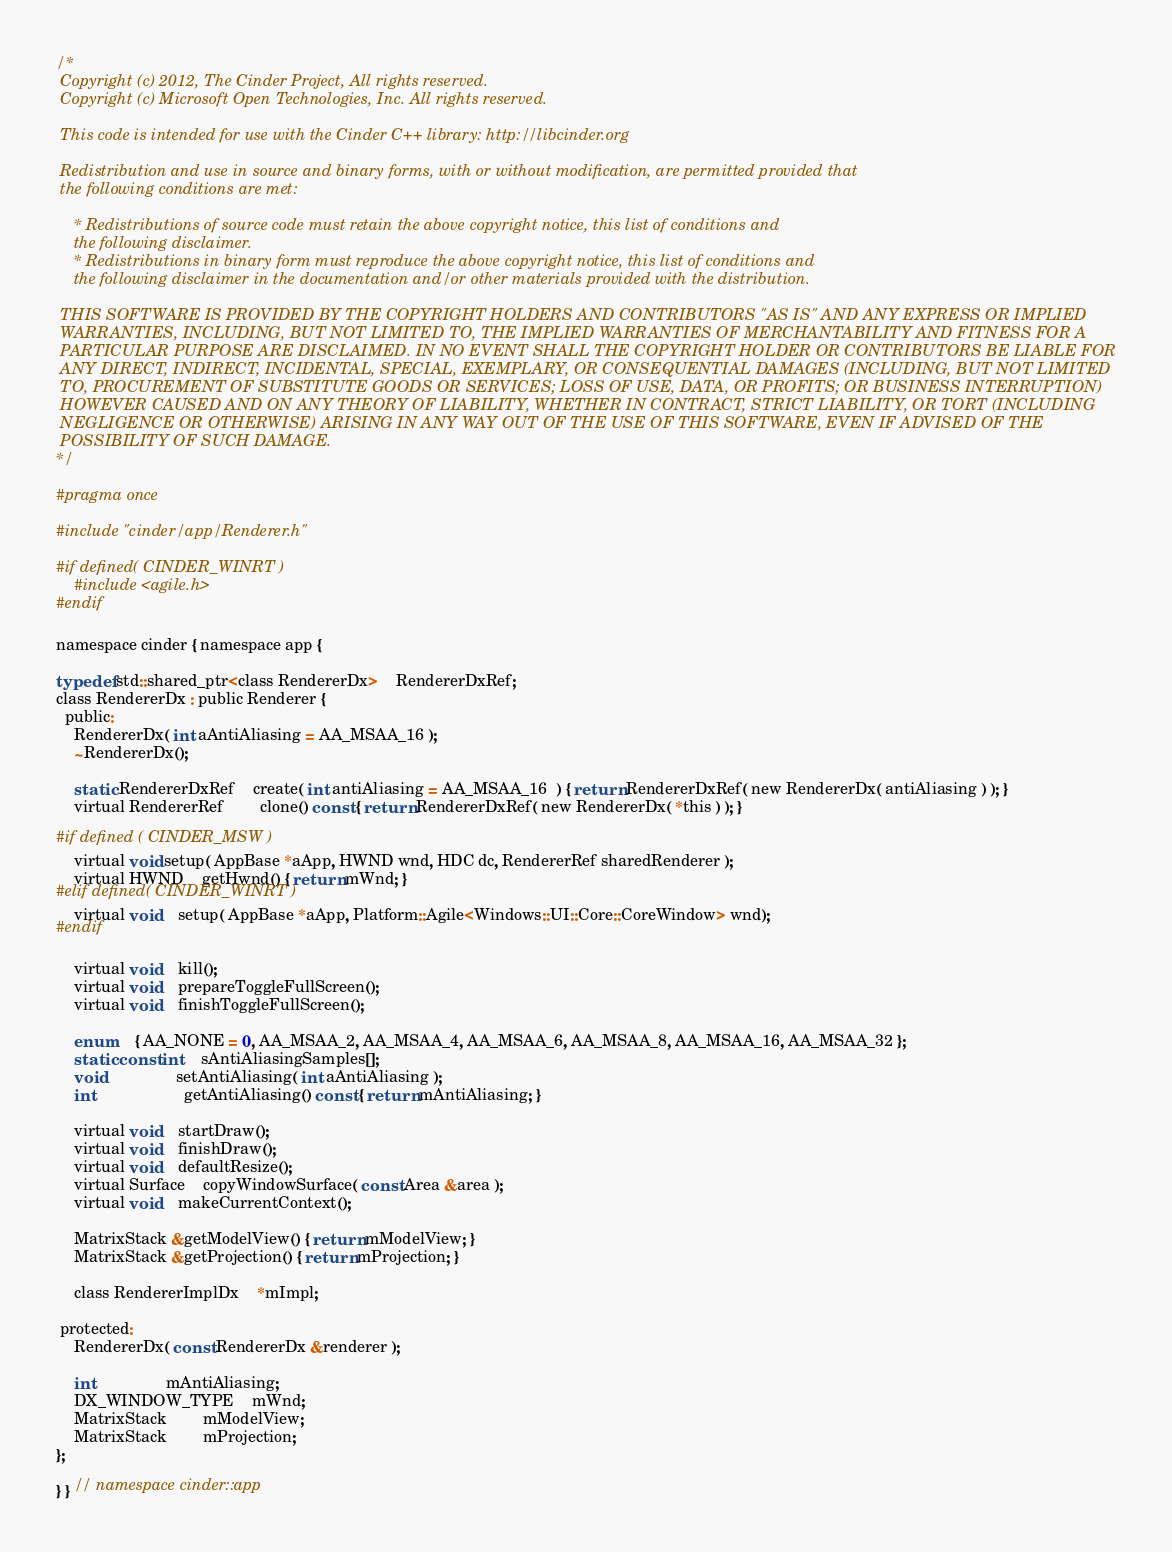<code> <loc_0><loc_0><loc_500><loc_500><_C_>/*  
 Copyright (c) 2012, The Cinder Project, All rights reserved.
 Copyright (c) Microsoft Open Technologies, Inc. All rights reserved.

 This code is intended for use with the Cinder C++ library: http://libcinder.org

 Redistribution and use in source and binary forms, with or without modification, are permitted provided that
 the following conditions are met:

    * Redistributions of source code must retain the above copyright notice, this list of conditions and
	the following disclaimer.
    * Redistributions in binary form must reproduce the above copyright notice, this list of conditions and
	the following disclaimer in the documentation and/or other materials provided with the distribution.

 THIS SOFTWARE IS PROVIDED BY THE COPYRIGHT HOLDERS AND CONTRIBUTORS "AS IS" AND ANY EXPRESS OR IMPLIED
 WARRANTIES, INCLUDING, BUT NOT LIMITED TO, THE IMPLIED WARRANTIES OF MERCHANTABILITY AND FITNESS FOR A
 PARTICULAR PURPOSE ARE DISCLAIMED. IN NO EVENT SHALL THE COPYRIGHT HOLDER OR CONTRIBUTORS BE LIABLE FOR
 ANY DIRECT, INDIRECT, INCIDENTAL, SPECIAL, EXEMPLARY, OR CONSEQUENTIAL DAMAGES (INCLUDING, BUT NOT LIMITED
 TO, PROCUREMENT OF SUBSTITUTE GOODS OR SERVICES; LOSS OF USE, DATA, OR PROFITS; OR BUSINESS INTERRUPTION)
 HOWEVER CAUSED AND ON ANY THEORY OF LIABILITY, WHETHER IN CONTRACT, STRICT LIABILITY, OR TORT (INCLUDING
 NEGLIGENCE OR OTHERWISE) ARISING IN ANY WAY OUT OF THE USE OF THIS SOFTWARE, EVEN IF ADVISED OF THE
 POSSIBILITY OF SUCH DAMAGE.
*/

#pragma once

#include "cinder/app/Renderer.h"

#if defined( CINDER_WINRT )
	#include <agile.h>
#endif

namespace cinder { namespace app {

typedef std::shared_ptr<class RendererDx>	RendererDxRef;
class RendererDx : public Renderer {
  public:
	RendererDx( int aAntiAliasing = AA_MSAA_16 );
	~RendererDx();
	
	static RendererDxRef	create( int antiAliasing = AA_MSAA_16  ) { return RendererDxRef( new RendererDx( antiAliasing ) ); }
	virtual RendererRef		clone() const { return RendererDxRef( new RendererDx( *this ) ); }

#if defined ( CINDER_MSW )
	virtual void setup( AppBase *aApp, HWND wnd, HDC dc, RendererRef sharedRenderer );
	virtual HWND	getHwnd() { return mWnd; }
#elif defined( CINDER_WINRT )
	virtual void	setup( AppBase *aApp, Platform::Agile<Windows::UI::Core::CoreWindow> wnd);
#endif

	virtual void	kill();
	virtual void	prepareToggleFullScreen();
	virtual void	finishToggleFullScreen();

	enum	{ AA_NONE = 0, AA_MSAA_2, AA_MSAA_4, AA_MSAA_6, AA_MSAA_8, AA_MSAA_16, AA_MSAA_32 };
	static const int	sAntiAliasingSamples[];
	void				setAntiAliasing( int aAntiAliasing );
	int					getAntiAliasing() const { return mAntiAliasing; }

	virtual void	startDraw();
	virtual void	finishDraw();
	virtual void	defaultResize();
	virtual Surface	copyWindowSurface( const Area &area );
	virtual void	makeCurrentContext();

	MatrixStack &getModelView() { return mModelView; }
	MatrixStack &getProjection() { return mProjection; }

	class RendererImplDx	*mImpl;
	
 protected:
	RendererDx( const RendererDx &renderer );

	int				mAntiAliasing;
	DX_WINDOW_TYPE	mWnd;
	MatrixStack		mModelView;
	MatrixStack		mProjection;
};

} } // namespace cinder::app</code> 